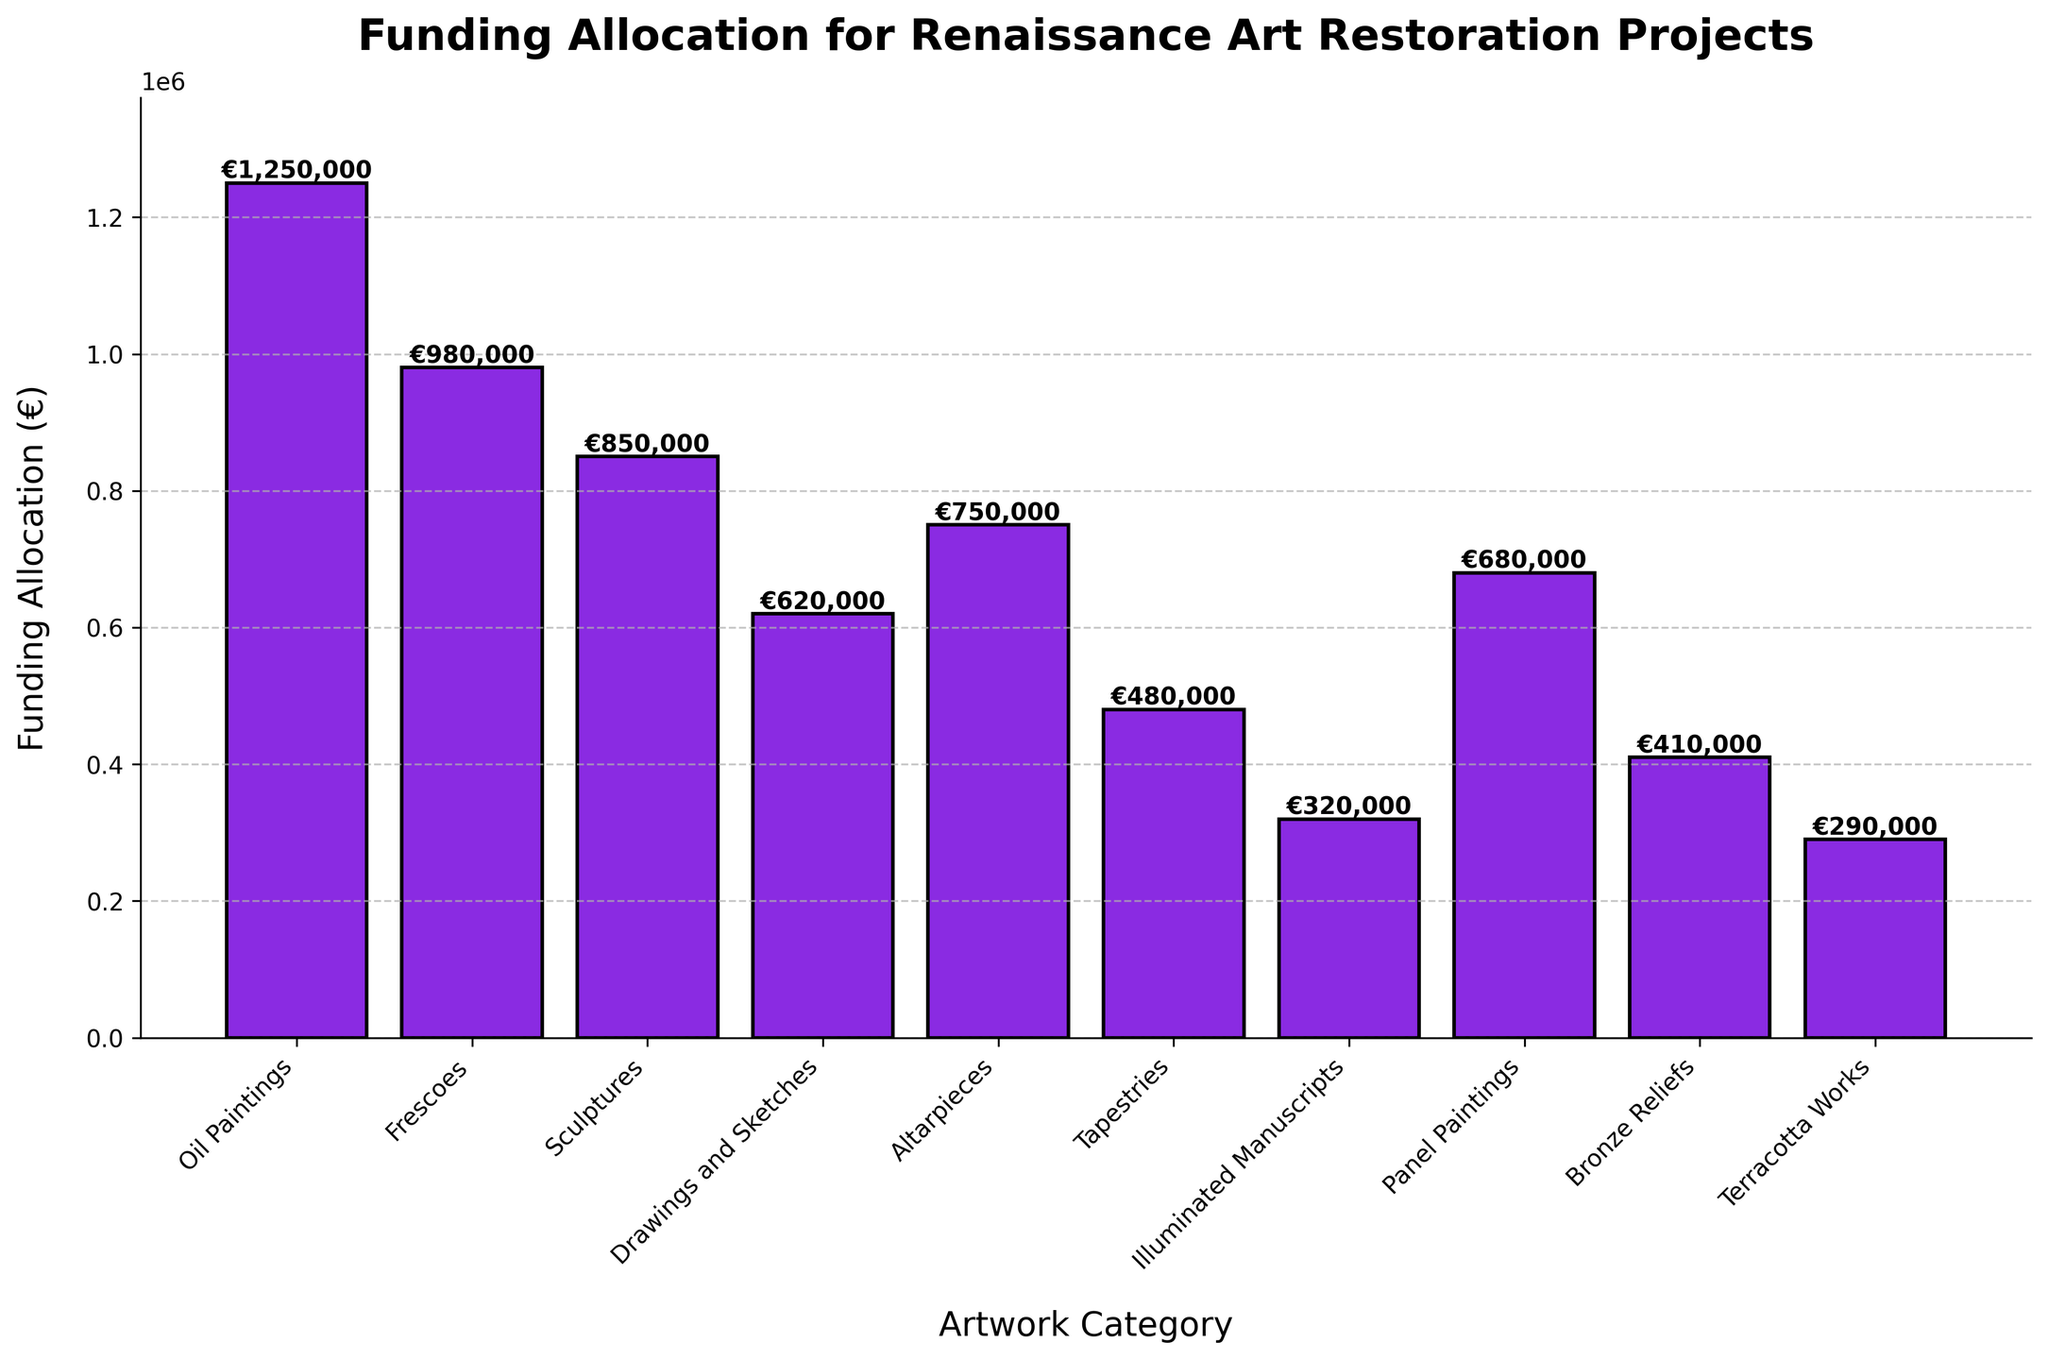Which artwork category received the highest funding allocation? To determine which artwork category received the highest funding, look at the bar chart and identify the tallest bar. The category at the top represents the highest allocation.
Answer: Oil Paintings Which artwork category received the lowest funding allocation? To find the category with the lowest funding, identify the shortest bar in the chart. The category at the bottom of this bar shows the lowest allocation.
Answer: Terracotta Works How much more funding did frescoes receive than illuminated manuscripts? First, check the bar lengths for Frescoes and Illuminated Manuscripts. Frescoes received €980,000 and Illuminated Manuscripts received €320,000. Subtract the smaller amount from the larger one: €980,000 - €320,000.
Answer: €660,000 What is the total funding allocation for all artwork categories combined? To find the total funding, sum the funding amounts for all categories: €1,250,000 + €980,000 + €850,000 + €620,000 + €750,000 + €480,000 + €320,000 + €680,000 + €410,000 + €290,000.
Answer: €6,630,000 Which categories have funding allocations greater than €800,000? Examine the bars to identify those that extend above €800,000. The categories whose bars surpass this threshold represent allocations greater than €800,000.
Answer: Oil Paintings, Frescoes, Sculptures By how much does the funding for Altarpieces fall short of that for Oil Paintings? Check the funding amounts for both Altarpieces and Oil Paintings. Altarpieces received €750,000 and Oil Paintings €1,250,000. Subtract the Altarpiece allocation from the Oil Paintings allocation: €1,250,000 - €750,000.
Answer: €500,000 What is the average funding allocation across all artwork categories? Add the funding amounts for all categories: €1,250,000 + €980,000 + €850,000 + €620,000 + €750,000 + €480,000 + €320,000 + €680,000 + €410,000 + €290,000 = €6,630,000. Divide by the number of categories: €6,630,000 / 10.
Answer: €663,000 Which category received nearly half the funding of Oil Paintings? Identify the funding for Oil Paintings (€1,250,000). Look for a category with funding around half of this, which is approximately €625,000.
Answer: Drawings and Sketches 